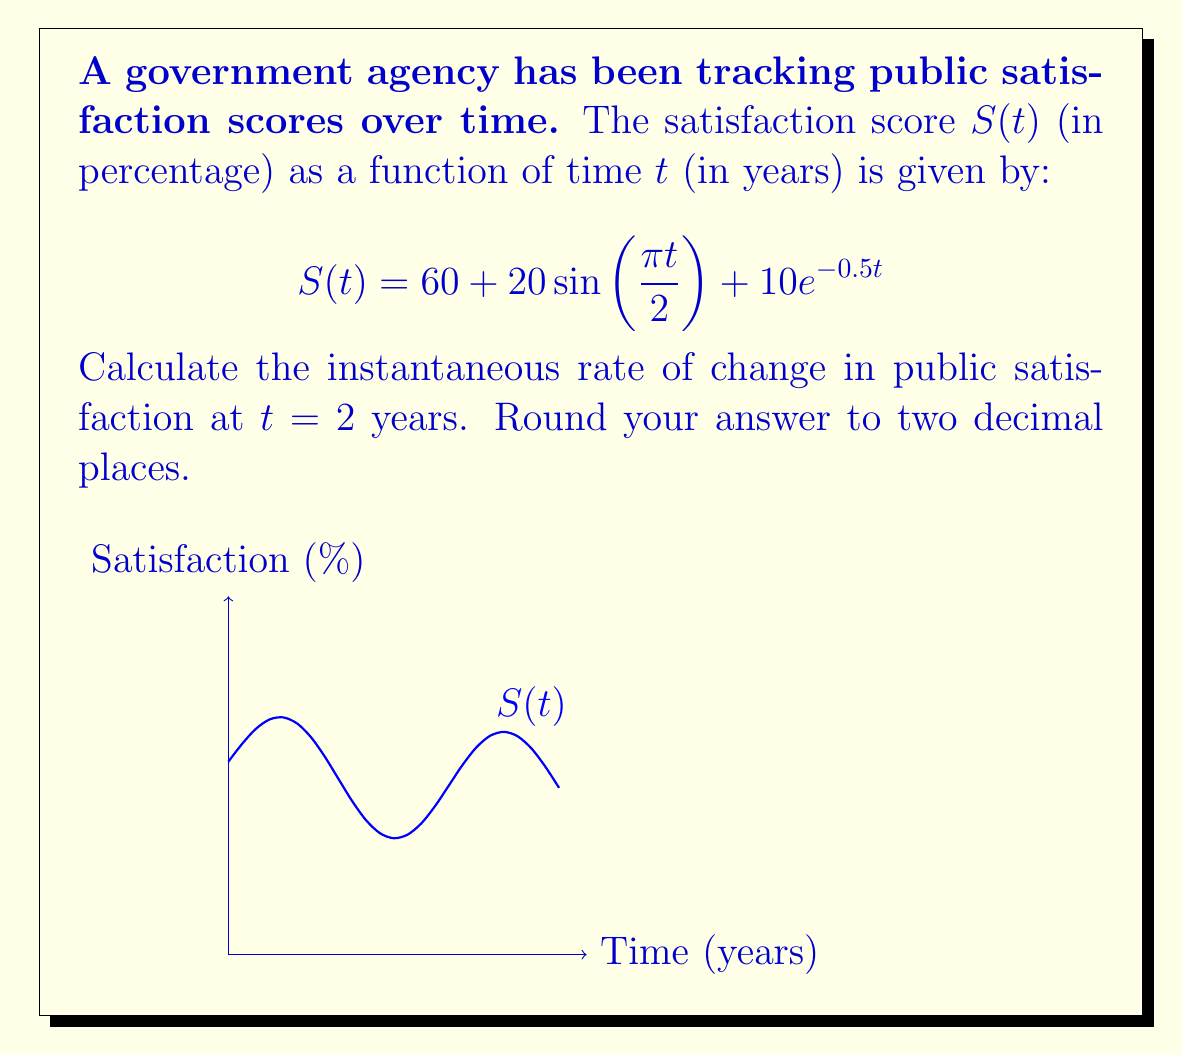Help me with this question. To find the instantaneous rate of change at $t = 2$, we need to calculate the derivative of $S(t)$ and evaluate it at $t = 2$.

1) First, let's find $S'(t)$ using the rules of differentiation:

   $$S'(t) = \frac{d}{dt}[60 + 20\sin(\frac{\pi t}{2}) + 10e^{-0.5t}]$$

2) The derivative of a constant (60) is 0.

3) For the sine term, we use the chain rule:
   $$\frac{d}{dt}[20\sin(\frac{\pi t}{2})] = 20 \cdot \cos(\frac{\pi t}{2}) \cdot \frac{\pi}{2} = 10\pi \cos(\frac{\pi t}{2})$$

4) For the exponential term, we use the chain rule again:
   $$\frac{d}{dt}[10e^{-0.5t}] = 10 \cdot (-0.5) \cdot e^{-0.5t} = -5e^{-0.5t}$$

5) Combining these results:
   $$S'(t) = 10\pi \cos(\frac{\pi t}{2}) - 5e^{-0.5t}$$

6) Now, we evaluate $S'(2)$:
   $$S'(2) = 10\pi \cos(\frac{\pi \cdot 2}{2}) - 5e^{-0.5 \cdot 2}$$
   $$= 10\pi \cos(\pi) - 5e^{-1}$$
   $$= -10\pi - 5e^{-1}$$

7) Calculate the numerical value and round to two decimal places:
   $$\approx -31.37 - 1.84 = -33.21$$

Therefore, the instantaneous rate of change in public satisfaction at $t = 2$ years is approximately -33.21% per year.
Answer: $-33.21\%$ per year 